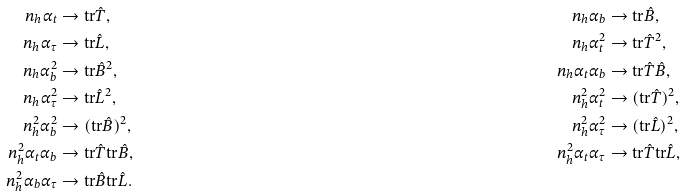<formula> <loc_0><loc_0><loc_500><loc_500>n _ { h } \alpha _ { t } & \rightarrow \text {tr} \hat { T } , & n _ { h } \alpha _ { b } & \rightarrow \text {tr} \hat { B } , \\ n _ { h } \alpha _ { \tau } & \rightarrow \text {tr} \hat { L } , & n _ { h } \alpha _ { t } ^ { 2 } & \rightarrow \text {tr} \hat { T } ^ { 2 } , \\ n _ { h } \alpha _ { b } ^ { 2 } & \rightarrow \text {tr} \hat { B } ^ { 2 } , & n _ { h } \alpha _ { t } \alpha _ { b } & \rightarrow \text {tr} \hat { T } \hat { B } , \\ n _ { h } \alpha _ { \tau } ^ { 2 } & \rightarrow \text {tr} \hat { L } ^ { 2 } , & n _ { h } ^ { 2 } \alpha _ { t } ^ { 2 } & \rightarrow ( \text {tr} \hat { T } ) ^ { 2 } , \\ n _ { h } ^ { 2 } \alpha _ { b } ^ { 2 } & \rightarrow ( \text {tr} \hat { B } ) ^ { 2 } , & n _ { h } ^ { 2 } \alpha _ { \tau } ^ { 2 } & \rightarrow ( \text {tr} \hat { L } ) ^ { 2 } , \\ n _ { h } ^ { 2 } \alpha _ { t } \alpha _ { b } & \rightarrow \text {tr} \hat { T } \text {tr} \hat { B } , & n _ { h } ^ { 2 } \alpha _ { t } \alpha _ { \tau } & \rightarrow \text {tr} \hat { T } \text {tr} \hat { L } , \\ n _ { h } ^ { 2 } \alpha _ { b } \alpha _ { \tau } & \rightarrow \text {tr} \hat { B } \text {tr} \hat { L } .</formula> 